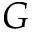<formula> <loc_0><loc_0><loc_500><loc_500>G</formula> 